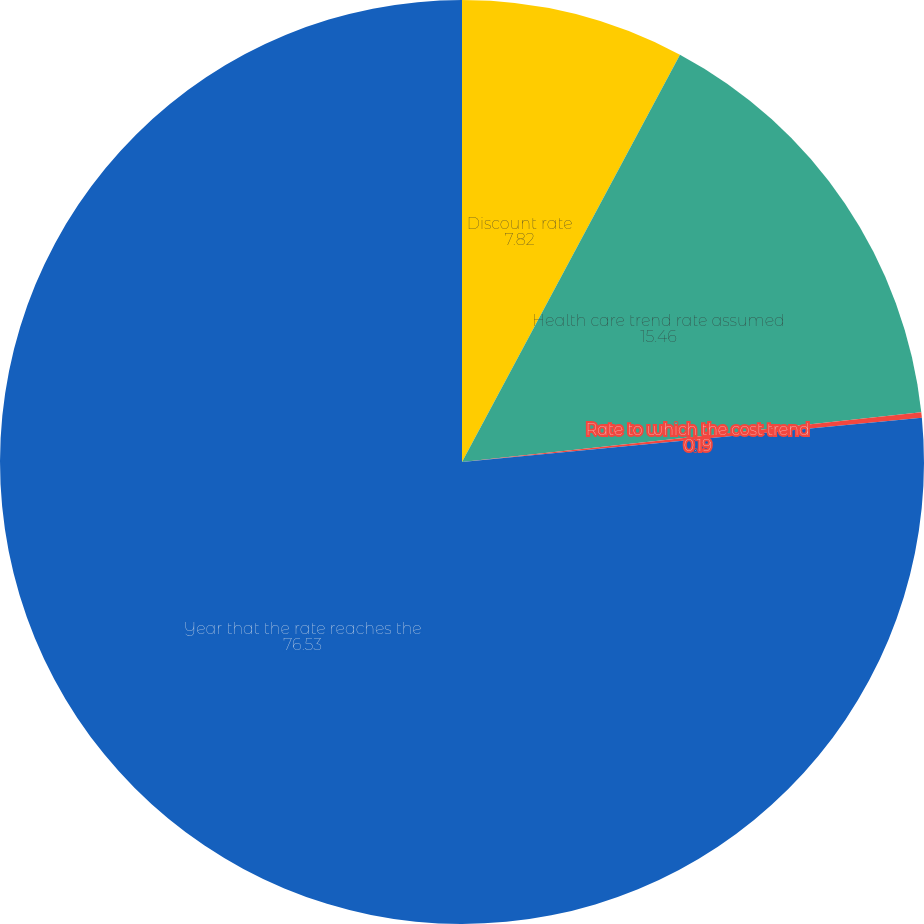<chart> <loc_0><loc_0><loc_500><loc_500><pie_chart><fcel>Discount rate<fcel>Health care trend rate assumed<fcel>Rate to which the cost trend<fcel>Year that the rate reaches the<nl><fcel>7.82%<fcel>15.46%<fcel>0.19%<fcel>76.53%<nl></chart> 